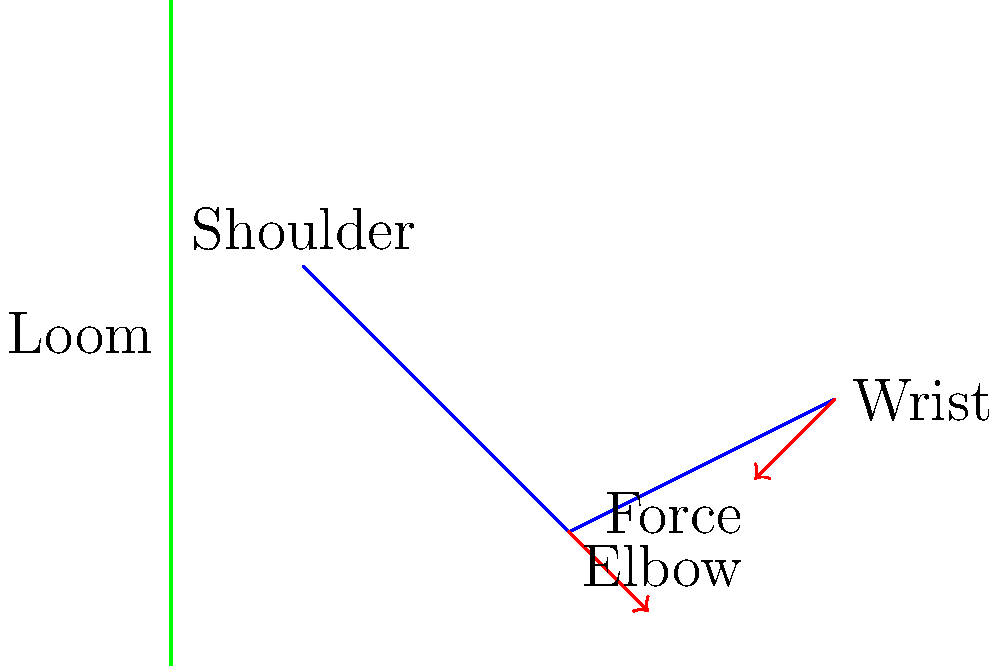Based on the skeletal diagram of an arm during traditional Native American weaving, what biomechanical principle is most relevant in assessing the ergonomic stress on the wrist joint? Explain your reasoning considering the posture and repetitive motions involved in this activity. To answer this question, we need to consider several biomechanical factors:

1. Joint Angles: The wrist is slightly extended, which can increase stress on the joint.

2. Moment Arms: The distance between the applied force (at the hand) and the wrist joint creates a moment arm, increasing the torque on the wrist.

3. Repetitive Motion: Weaving involves repetitive movements, which can lead to cumulative stress.

4. Force Direction: The force applied during weaving is not aligned with the long axis of the forearm, creating shear forces on the wrist.

5. Lever System: The forearm acts as a third-class lever, with the elbow as the fulcrum, muscles providing effort, and the weaving force as resistance.

Considering these factors, the most relevant biomechanical principle is the concept of joint moments or torques. The combination of the wrist position, the force applied during weaving, and the moment arm created by the hand's distance from the wrist joint results in a significant torque on the wrist.

This torque is calculated as:

$$\tau = F \times d$$

Where $\tau$ is the torque, $F$ is the force applied, and $d$ is the perpendicular distance from the joint to the line of force action (moment arm).

The repetitive nature of weaving motions means this torque is applied cyclically, potentially leading to fatigue and overuse injuries if not properly managed through ergonomic techniques.
Answer: Joint moment (torque) analysis 